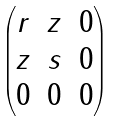<formula> <loc_0><loc_0><loc_500><loc_500>\begin{pmatrix} r & z & 0 \\ z & s & 0 \\ 0 & 0 & 0 \end{pmatrix}</formula> 